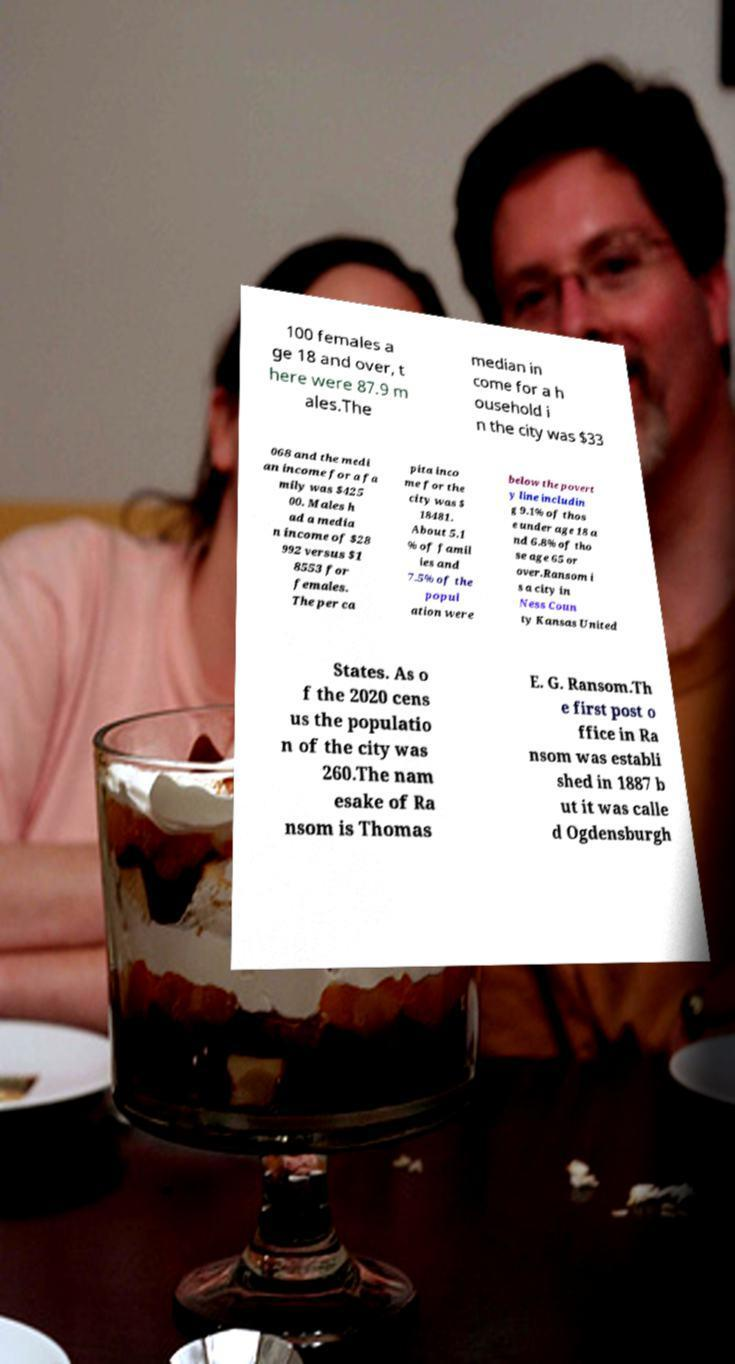What messages or text are displayed in this image? I need them in a readable, typed format. 100 females a ge 18 and over, t here were 87.9 m ales.The median in come for a h ousehold i n the city was $33 068 and the medi an income for a fa mily was $425 00. Males h ad a media n income of $28 992 versus $1 8553 for females. The per ca pita inco me for the city was $ 18481. About 5.1 % of famil ies and 7.5% of the popul ation were below the povert y line includin g 9.1% of thos e under age 18 a nd 6.8% of tho se age 65 or over.Ransom i s a city in Ness Coun ty Kansas United States. As o f the 2020 cens us the populatio n of the city was 260.The nam esake of Ra nsom is Thomas E. G. Ransom.Th e first post o ffice in Ra nsom was establi shed in 1887 b ut it was calle d Ogdensburgh 